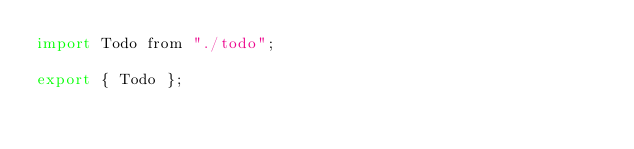<code> <loc_0><loc_0><loc_500><loc_500><_JavaScript_>import Todo from "./todo";

export { Todo };
</code> 